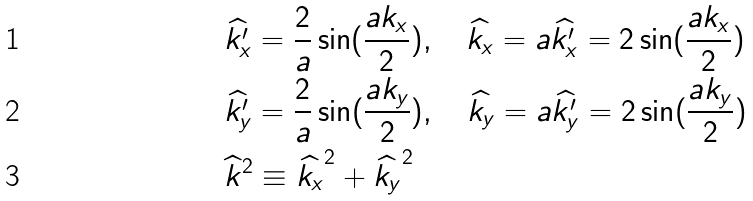<formula> <loc_0><loc_0><loc_500><loc_500>& \widehat { k ^ { \prime } _ { x } } = \frac { 2 } { a } \sin ( \frac { a k _ { x } } { 2 } ) , \quad \widehat { k _ { x } } = a \widehat { k ^ { \prime } _ { x } } = 2 \sin ( \frac { a k _ { x } } { 2 } ) \\ & \widehat { k ^ { \prime } _ { y } } = \frac { 2 } { a } \sin ( \frac { a k _ { y } } { 2 } ) , \quad \widehat { k _ { y } } = a \widehat { k ^ { \prime } _ { y } } = 2 \sin ( \frac { a k _ { y } } { 2 } ) \\ & \widehat { k } ^ { 2 } \equiv \widehat { k _ { x } } ^ { 2 } + \widehat { k _ { y } } ^ { 2 }</formula> 